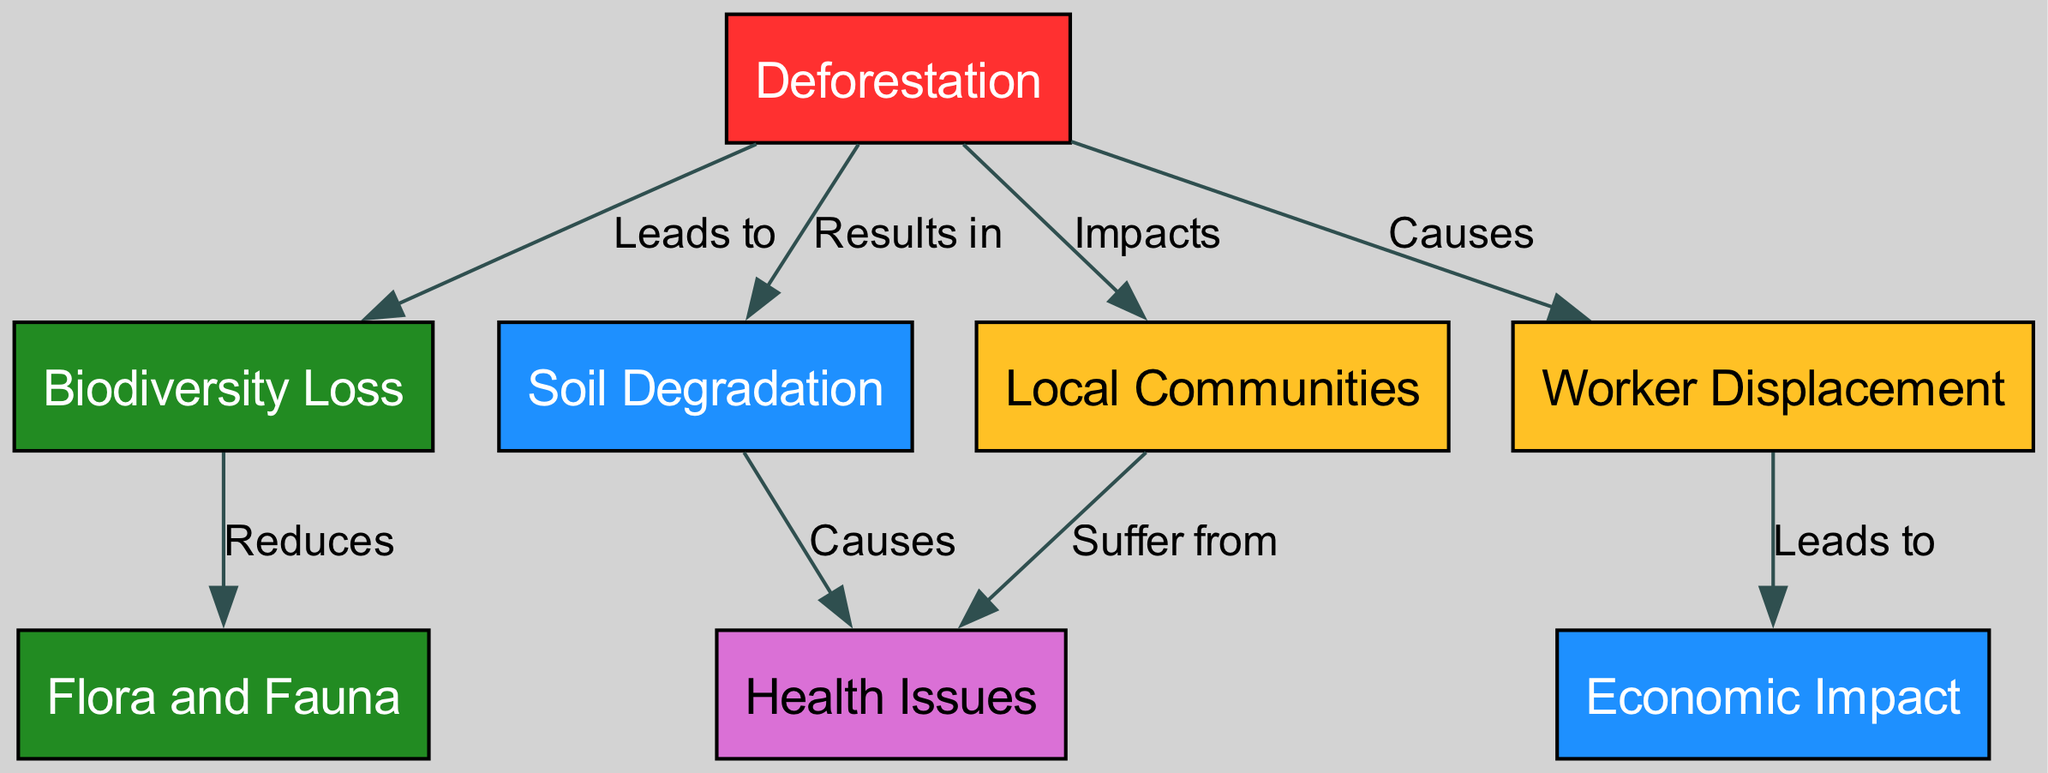What is the main cause of Worker Displacement? The diagram shows that Worker Displacement is caused by Deforestation, as indicated by the direct relationship labeled "Causes." Following the edges from Worker Displacement back, we find it directly connects to Deforestation.
Answer: Deforestation How many nodes are in the diagram? By counting the nodes listed in the diagram data, there are a total of 8 different nodes representing different concepts related to deforestation and its impacts.
Answer: 8 What does Deforestation lead to in terms of biodiversity? The diagram indicates that Deforestation leads to Biodiversity Loss, as shown by the direct relationship labeled "Leads to." By following this edge, we see this specific cause-effect relationship.
Answer: Biodiversity Loss Which node suffers from Health Issues according to the diagram? The diagram shows that Local Communities suffer from Health Issues. The edge labeled "Suffer from" connects Local Communities directly to Health Issues, indicating this relationship.
Answer: Local Communities What is one effect of Soil Degradation? The diagram specifies that Soil Degradation causes Health Issues. By analyzing the edge labeled "Causes," we see the impact of Soil Degradation leads to this specific outcome.
Answer: Health Issues What is reduced due to Biodiversity Loss? The diagram states that Biodiversity Loss reduces Flora and Fauna, as indicated by the edge labeled "Reduces." This shows a direct impact on plant and animal life resulting from biodiversity decline.
Answer: Flora and Fauna How does Worker Displacement affect the local economy? Worker Displacement leads to Economic Impact, as indicated by the diagram connection labeled "Leads to." This edge shows the cause-effect relationship between these two nodes.
Answer: Economic Impact What connection exists between Deforestation and Soil Degradation? The diagram shows that Deforestation results in Soil Degradation, linked by the edge labeled "Results in." This indicates a direct effect of deforestation on soil quality.
Answer: Soil Degradation 